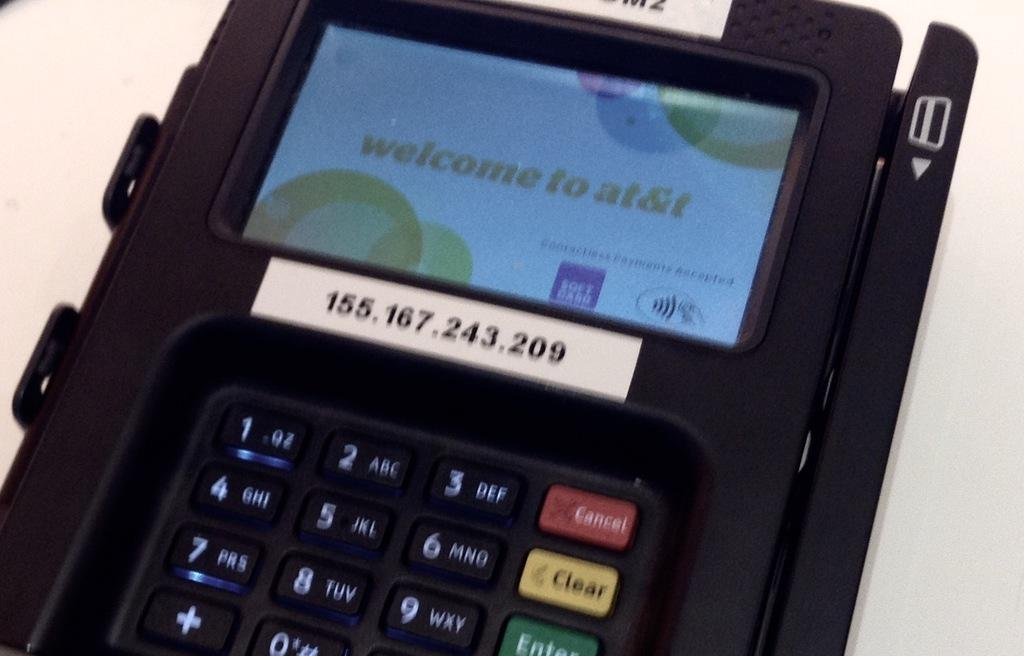<image>
Describe the image concisely. a machine with Welcome to At&T written on it 